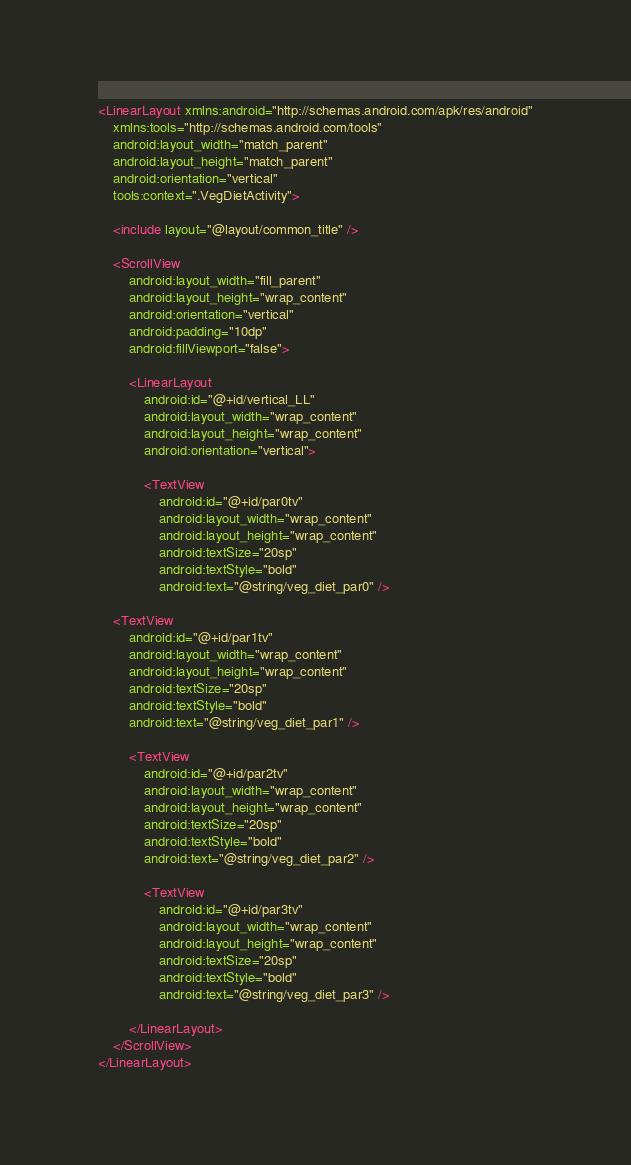<code> <loc_0><loc_0><loc_500><loc_500><_XML_><LinearLayout xmlns:android="http://schemas.android.com/apk/res/android"
    xmlns:tools="http://schemas.android.com/tools"
    android:layout_width="match_parent"
    android:layout_height="match_parent"
    android:orientation="vertical"
    tools:context=".VegDietActivity">

    <include layout="@layout/common_title" />

    <ScrollView
        android:layout_width="fill_parent"
        android:layout_height="wrap_content"
        android:orientation="vertical"
        android:padding="10dp"
        android:fillViewport="false">

        <LinearLayout
            android:id="@+id/vertical_LL"
            android:layout_width="wrap_content"
            android:layout_height="wrap_content"
            android:orientation="vertical">

            <TextView
                android:id="@+id/par0tv"
                android:layout_width="wrap_content"
                android:layout_height="wrap_content"
                android:textSize="20sp"
                android:textStyle="bold"
                android:text="@string/veg_diet_par0" />

    <TextView
        android:id="@+id/par1tv"
        android:layout_width="wrap_content"
        android:layout_height="wrap_content"
        android:textSize="20sp"
        android:textStyle="bold"
        android:text="@string/veg_diet_par1" />

        <TextView
            android:id="@+id/par2tv"
            android:layout_width="wrap_content"
            android:layout_height="wrap_content"
            android:textSize="20sp"
            android:textStyle="bold"
            android:text="@string/veg_diet_par2" />

            <TextView
                android:id="@+id/par3tv"
                android:layout_width="wrap_content"
                android:layout_height="wrap_content"
                android:textSize="20sp"
                android:textStyle="bold"
                android:text="@string/veg_diet_par3" />

        </LinearLayout>
    </ScrollView>
</LinearLayout>



</code> 